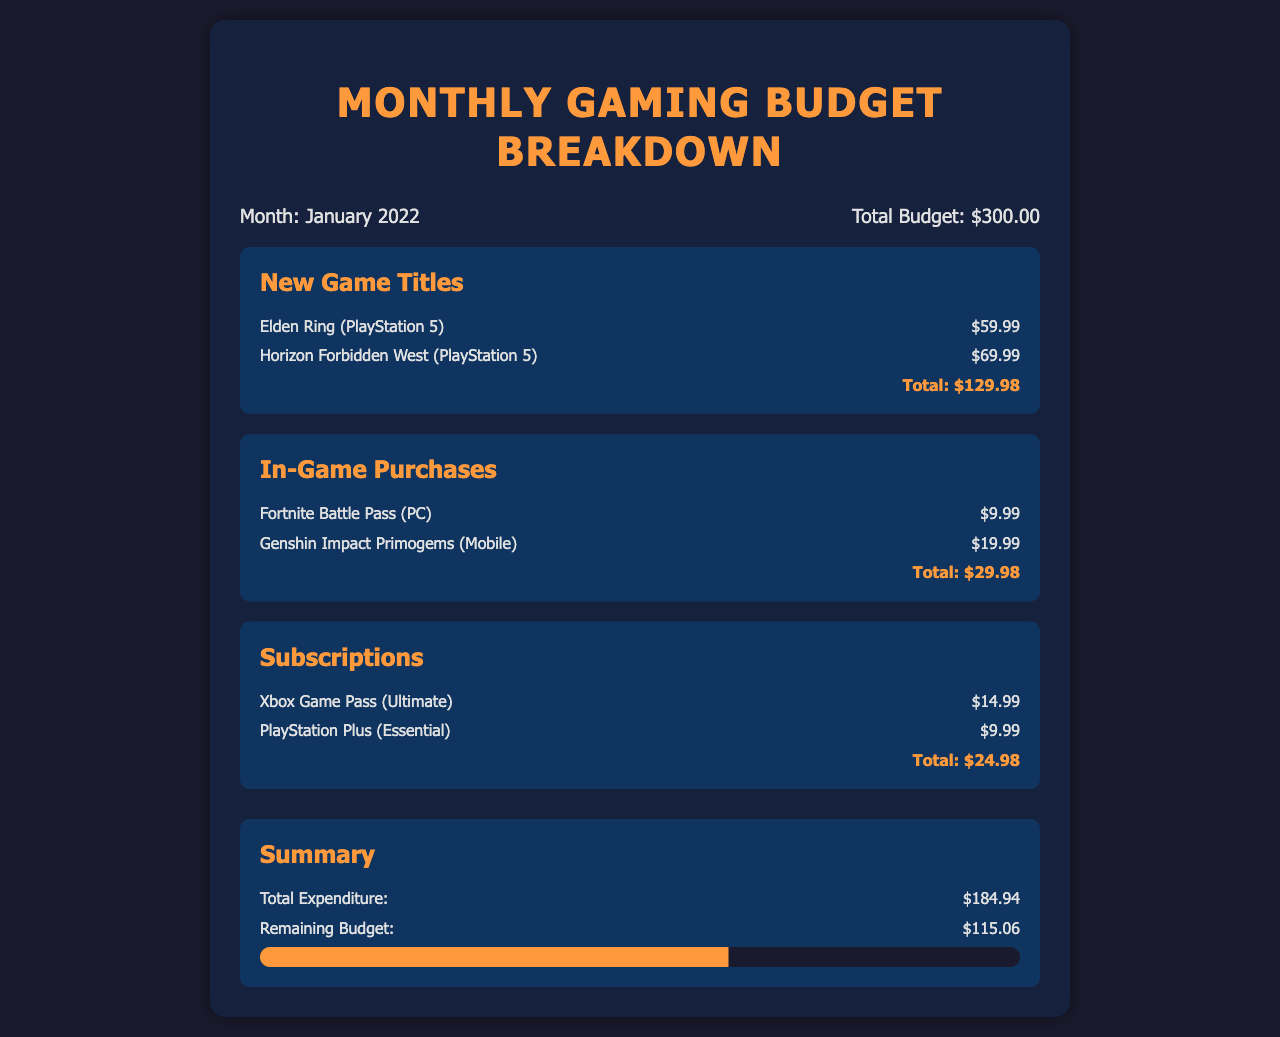What is the total budget for January 2022? The document states a total budget of $300.00 for January 2022.
Answer: $300.00 How much was spent on new game titles? The total expenditure on new game titles is provided in the document, which adds up to $129.98.
Answer: $129.98 What is the cost of Horizon Forbidden West? The document lists the cost of Horizon Forbidden West as $69.99.
Answer: $69.99 What is the total expenditure stated in the summary? The summary explicitly states the total expenditure as $184.94.
Answer: $184.94 How much is left in the budget after expenditures? The remaining budget after expenditures is indicated in the summary as $115.06.
Answer: $115.06 How many new game titles are listed? The document contains two new game titles: Elden Ring and Horizon Forbidden West.
Answer: Two What is the cost of the Xbox Game Pass (Ultimate) subscription? The document lists the Xbox Game Pass (Ultimate) subscription as costing $14.99.
Answer: $14.99 How much was spent on in-game purchases? The expenditure on in-game purchases is detailed in the document and totaled to $29.98.
Answer: $29.98 What is the sum of the costs for subscriptions? The total cost for subscriptions in the document sums up to $24.98.
Answer: $24.98 